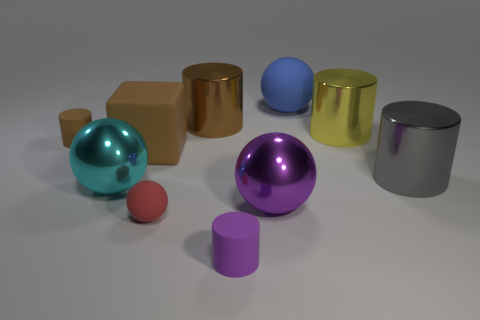Subtract all cyan spheres. How many spheres are left? 3 Subtract all tiny rubber cylinders. How many cylinders are left? 3 Subtract 1 spheres. How many spheres are left? 3 Subtract all gray cylinders. How many yellow balls are left? 0 Subtract all large blue shiny objects. Subtract all small red objects. How many objects are left? 9 Add 6 gray shiny cylinders. How many gray shiny cylinders are left? 7 Add 8 gray metallic things. How many gray metallic things exist? 9 Subtract 0 yellow spheres. How many objects are left? 10 Subtract all blocks. How many objects are left? 9 Subtract all gray spheres. Subtract all green cylinders. How many spheres are left? 4 